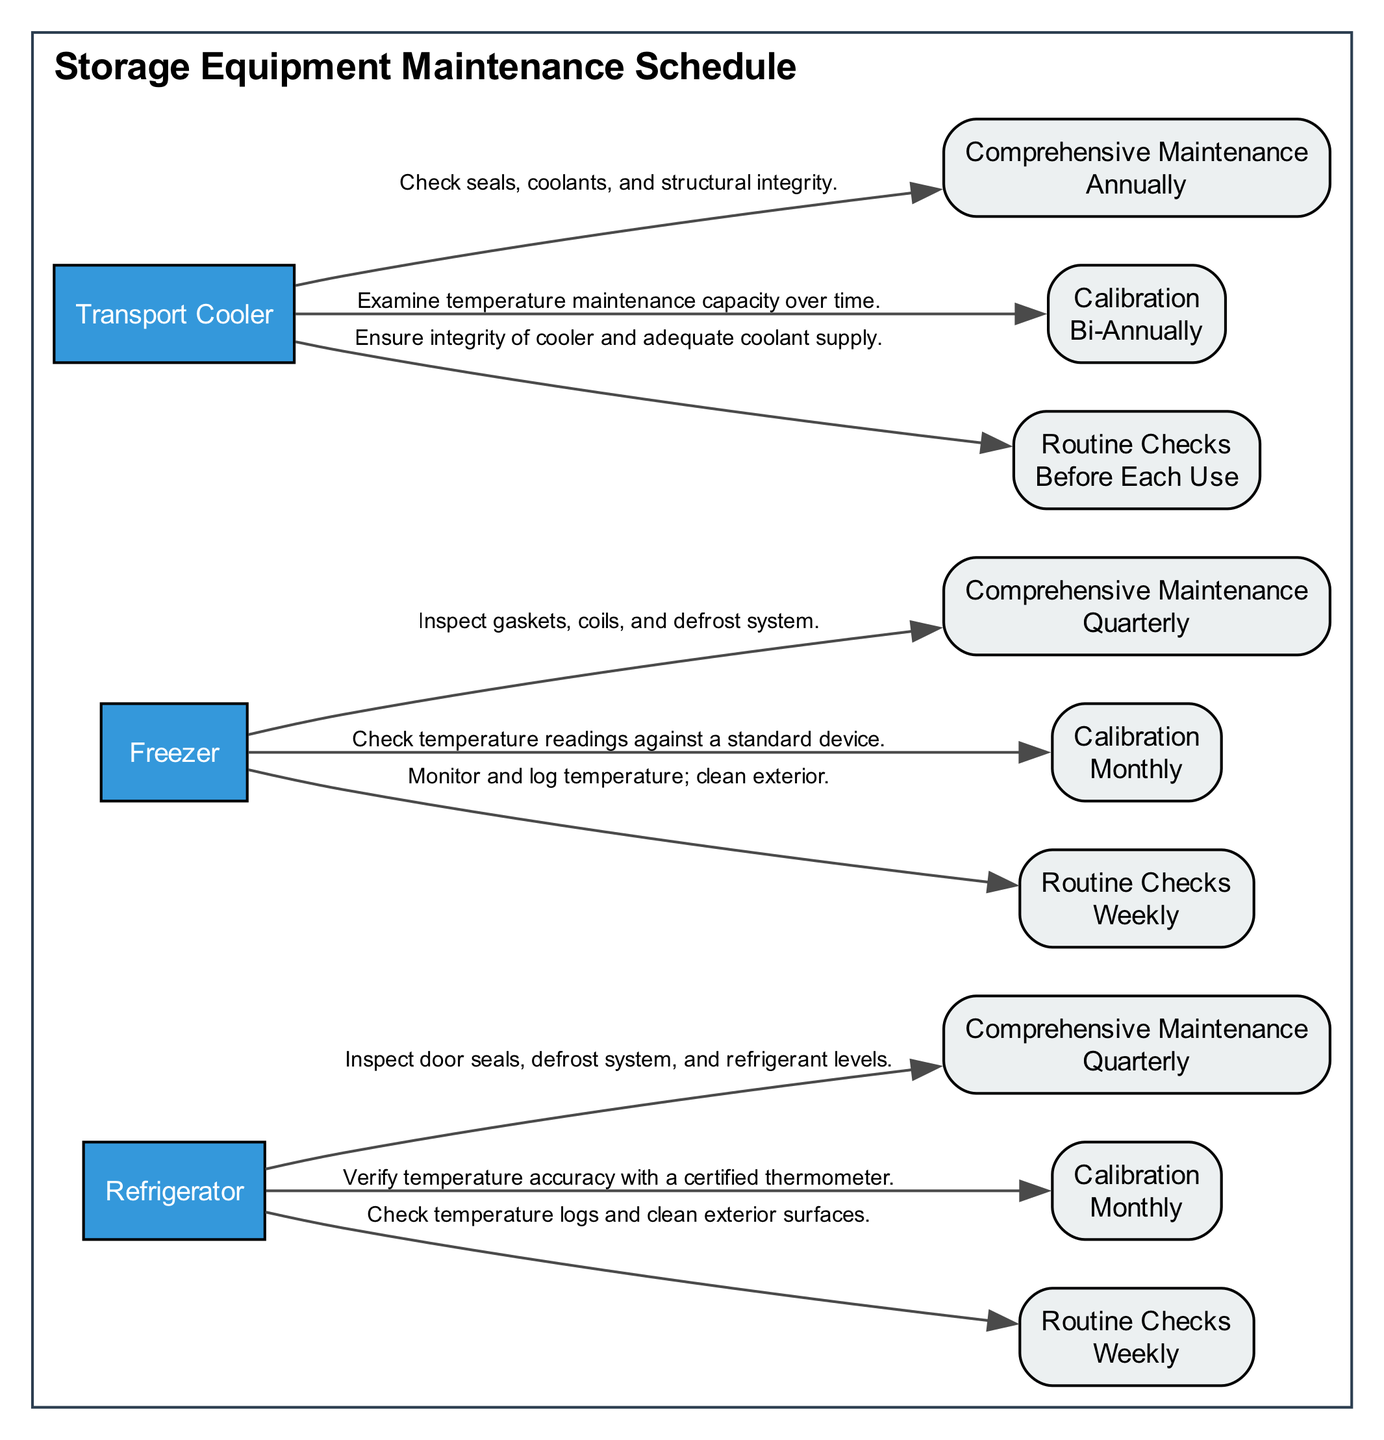What types of equipment are listed in the diagram? The diagram shows three types of equipment: Refrigerator, Freezer, and Transport Cooler. Each is represented as a node that names the equipment.
Answer: Refrigerator, Freezer, Transport Cooler How often are routine checks performed on the Freezer? The Freezer has routine checks scheduled weekly as indicated by the maintenance schedule in the diagram with the labeling of the corresponding task node.
Answer: Weekly What is the frequency of comprehensive maintenance for the Transport Cooler? The Transport Cooler requires comprehensive maintenance annually, which is illustrated through the frequency indicated in the schedule node linked to the Transport Cooler in the diagram.
Answer: Annually Which task for the Refrigerator is performed quarterly? The task labeled "Comprehensive Maintenance" for the Refrigerator is shown with quarterly frequency, directly answering the inquiry about the specific task by inspecting the corresponding node.
Answer: Comprehensive Maintenance How many total tasks are listed for the Freezer equipment? The Freezer has three tasks listed: Routine Checks, Calibration, and Comprehensive Maintenance. By counting the task nodes connected to it, we arrive at the total number of tasks.
Answer: 3 Which equipment requires calibration bi-annually? The diagram specifies that the Transport Cooler requires calibration bi-annually, with the information represented clearly within the task nodes connected to the equipment.
Answer: Transport Cooler What task is performed before each use of the Transport Cooler? The task that must be performed before each use of the Transport Cooler is "Routine Checks," as depicted within the maintenance schedule node and its description.
Answer: Routine Checks How many types of maintenance tasks are included for each piece of equipment? Each piece of equipment in the diagram has three types of maintenance tasks: Routine Checks, Calibration, and Comprehensive Maintenance, which can be confirmed by reviewing the tasks associated with each equipment node.
Answer: 3 